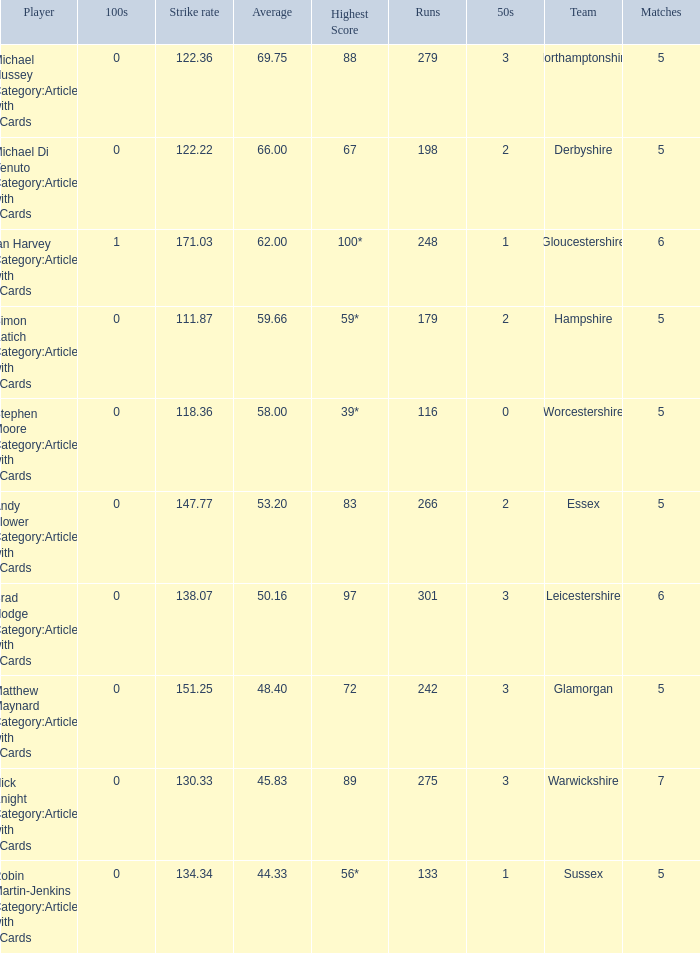What is the team Sussex' highest score? 56*. 